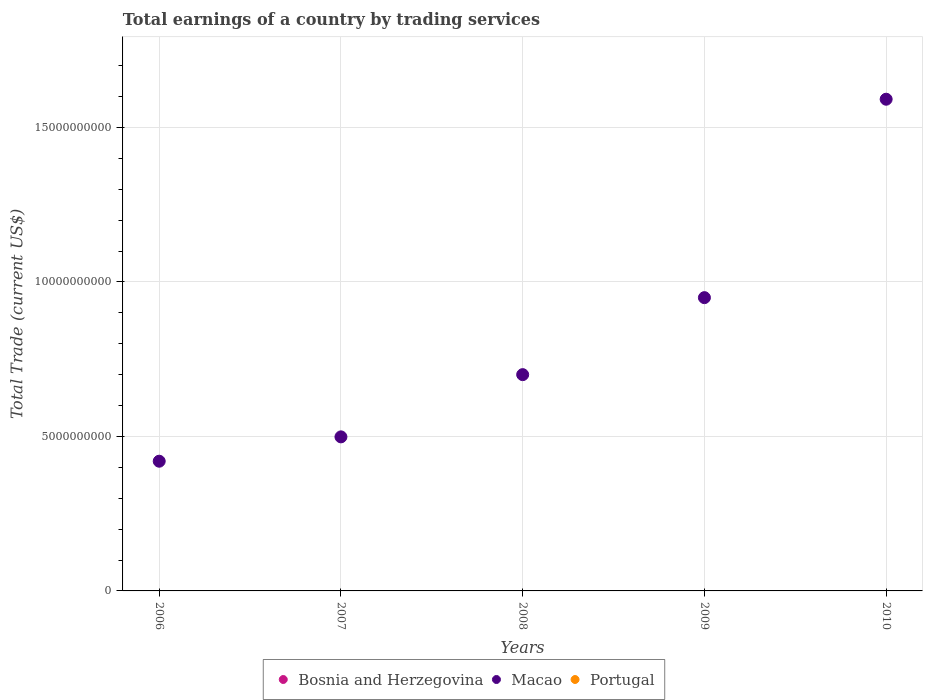What is the total earnings in Macao in 2008?
Your answer should be very brief. 7.00e+09. Across all years, what is the maximum total earnings in Macao?
Give a very brief answer. 1.59e+1. What is the difference between the total earnings in Macao in 2008 and that in 2010?
Provide a succinct answer. -8.92e+09. What is the difference between the total earnings in Macao in 2006 and the total earnings in Bosnia and Herzegovina in 2010?
Your response must be concise. 4.20e+09. What is the average total earnings in Portugal per year?
Your answer should be compact. 0. In how many years, is the total earnings in Macao greater than 11000000000 US$?
Offer a terse response. 1. Is the total earnings in Macao in 2008 less than that in 2010?
Offer a terse response. Yes. What is the difference between the highest and the second highest total earnings in Macao?
Your answer should be compact. 6.42e+09. What is the difference between the highest and the lowest total earnings in Macao?
Offer a terse response. 1.17e+1. Is the sum of the total earnings in Macao in 2006 and 2010 greater than the maximum total earnings in Portugal across all years?
Give a very brief answer. Yes. Is the total earnings in Macao strictly greater than the total earnings in Portugal over the years?
Give a very brief answer. Yes. Is the total earnings in Macao strictly less than the total earnings in Bosnia and Herzegovina over the years?
Your answer should be compact. No. How many dotlines are there?
Offer a very short reply. 1. How many years are there in the graph?
Keep it short and to the point. 5. What is the difference between two consecutive major ticks on the Y-axis?
Make the answer very short. 5.00e+09. Are the values on the major ticks of Y-axis written in scientific E-notation?
Make the answer very short. No. Where does the legend appear in the graph?
Your response must be concise. Bottom center. How are the legend labels stacked?
Ensure brevity in your answer.  Horizontal. What is the title of the graph?
Offer a terse response. Total earnings of a country by trading services. Does "Paraguay" appear as one of the legend labels in the graph?
Keep it short and to the point. No. What is the label or title of the X-axis?
Give a very brief answer. Years. What is the label or title of the Y-axis?
Keep it short and to the point. Total Trade (current US$). What is the Total Trade (current US$) of Bosnia and Herzegovina in 2006?
Ensure brevity in your answer.  0. What is the Total Trade (current US$) of Macao in 2006?
Give a very brief answer. 4.20e+09. What is the Total Trade (current US$) in Bosnia and Herzegovina in 2007?
Make the answer very short. 0. What is the Total Trade (current US$) of Macao in 2007?
Your response must be concise. 4.99e+09. What is the Total Trade (current US$) of Portugal in 2007?
Your response must be concise. 0. What is the Total Trade (current US$) of Macao in 2008?
Your response must be concise. 7.00e+09. What is the Total Trade (current US$) of Portugal in 2008?
Ensure brevity in your answer.  0. What is the Total Trade (current US$) in Bosnia and Herzegovina in 2009?
Offer a terse response. 0. What is the Total Trade (current US$) in Macao in 2009?
Your response must be concise. 9.49e+09. What is the Total Trade (current US$) of Bosnia and Herzegovina in 2010?
Provide a succinct answer. 0. What is the Total Trade (current US$) of Macao in 2010?
Keep it short and to the point. 1.59e+1. Across all years, what is the maximum Total Trade (current US$) of Macao?
Give a very brief answer. 1.59e+1. Across all years, what is the minimum Total Trade (current US$) in Macao?
Your answer should be compact. 4.20e+09. What is the total Total Trade (current US$) of Bosnia and Herzegovina in the graph?
Give a very brief answer. 0. What is the total Total Trade (current US$) of Macao in the graph?
Your answer should be compact. 4.16e+1. What is the difference between the Total Trade (current US$) in Macao in 2006 and that in 2007?
Offer a terse response. -7.88e+08. What is the difference between the Total Trade (current US$) of Macao in 2006 and that in 2008?
Ensure brevity in your answer.  -2.80e+09. What is the difference between the Total Trade (current US$) in Macao in 2006 and that in 2009?
Your answer should be compact. -5.29e+09. What is the difference between the Total Trade (current US$) in Macao in 2006 and that in 2010?
Your response must be concise. -1.17e+1. What is the difference between the Total Trade (current US$) of Macao in 2007 and that in 2008?
Your answer should be very brief. -2.01e+09. What is the difference between the Total Trade (current US$) of Macao in 2007 and that in 2009?
Ensure brevity in your answer.  -4.51e+09. What is the difference between the Total Trade (current US$) of Macao in 2007 and that in 2010?
Offer a very short reply. -1.09e+1. What is the difference between the Total Trade (current US$) of Macao in 2008 and that in 2009?
Make the answer very short. -2.49e+09. What is the difference between the Total Trade (current US$) of Macao in 2008 and that in 2010?
Your answer should be very brief. -8.92e+09. What is the difference between the Total Trade (current US$) in Macao in 2009 and that in 2010?
Give a very brief answer. -6.42e+09. What is the average Total Trade (current US$) in Bosnia and Herzegovina per year?
Provide a short and direct response. 0. What is the average Total Trade (current US$) of Macao per year?
Your answer should be compact. 8.32e+09. What is the average Total Trade (current US$) of Portugal per year?
Offer a very short reply. 0. What is the ratio of the Total Trade (current US$) in Macao in 2006 to that in 2007?
Your answer should be compact. 0.84. What is the ratio of the Total Trade (current US$) in Macao in 2006 to that in 2008?
Offer a terse response. 0.6. What is the ratio of the Total Trade (current US$) of Macao in 2006 to that in 2009?
Your response must be concise. 0.44. What is the ratio of the Total Trade (current US$) in Macao in 2006 to that in 2010?
Your answer should be very brief. 0.26. What is the ratio of the Total Trade (current US$) of Macao in 2007 to that in 2008?
Make the answer very short. 0.71. What is the ratio of the Total Trade (current US$) in Macao in 2007 to that in 2009?
Give a very brief answer. 0.53. What is the ratio of the Total Trade (current US$) in Macao in 2007 to that in 2010?
Your answer should be compact. 0.31. What is the ratio of the Total Trade (current US$) in Macao in 2008 to that in 2009?
Ensure brevity in your answer.  0.74. What is the ratio of the Total Trade (current US$) in Macao in 2008 to that in 2010?
Ensure brevity in your answer.  0.44. What is the ratio of the Total Trade (current US$) in Macao in 2009 to that in 2010?
Make the answer very short. 0.6. What is the difference between the highest and the second highest Total Trade (current US$) of Macao?
Ensure brevity in your answer.  6.42e+09. What is the difference between the highest and the lowest Total Trade (current US$) in Macao?
Give a very brief answer. 1.17e+1. 